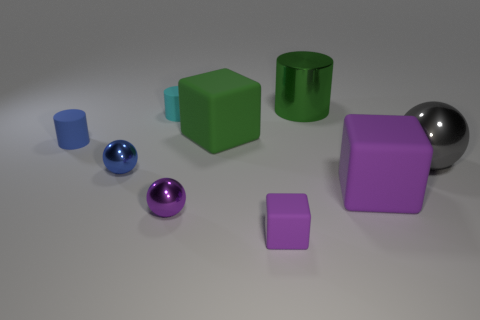There is a tiny rubber thing in front of the large ball; is it the same shape as the big green thing in front of the large cylinder?
Keep it short and to the point. Yes. What is the size of the block that is the same color as the metal cylinder?
Your answer should be very brief. Large. What number of other things are the same size as the cyan object?
Your response must be concise. 4. There is a big shiny sphere; is its color the same as the large matte thing that is to the right of the green cylinder?
Keep it short and to the point. No. Are there fewer big cubes that are in front of the big gray metal thing than tiny objects that are behind the big green cube?
Your response must be concise. No. What is the color of the object that is both right of the purple shiny object and behind the big green rubber thing?
Your answer should be very brief. Green. Is the size of the purple shiny thing the same as the shiny thing behind the gray object?
Offer a terse response. No. There is a tiny thing that is behind the blue cylinder; what is its shape?
Give a very brief answer. Cylinder. Are there any other things that are the same material as the big purple thing?
Your response must be concise. Yes. Is the number of purple metal things on the right side of the big ball greater than the number of big gray things?
Your answer should be very brief. No. 